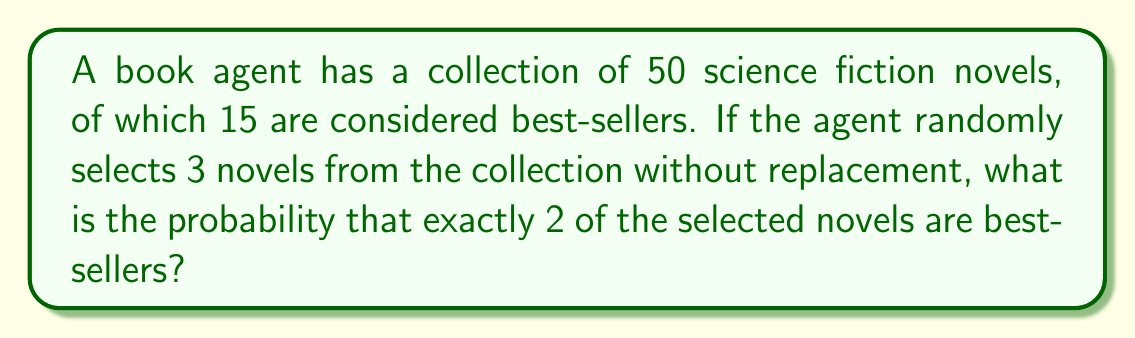Provide a solution to this math problem. To solve this problem, we'll use the hypergeometric distribution, which is appropriate for sampling without replacement from a finite population.

Let's define our parameters:
- N = 50 (total number of novels)
- K = 15 (number of best-sellers)
- n = 3 (number of novels selected)
- k = 2 (number of best-sellers we want in our selection)

The probability of selecting exactly 2 best-sellers out of 3 selections is given by:

$$P(X=2) = \frac{\binom{K}{k} \binom{N-K}{n-k}}{\binom{N}{n}}$$

Where $\binom{a}{b}$ represents the binomial coefficient "a choose b".

Step 1: Calculate $\binom{K}{k} = \binom{15}{2}$
$$\binom{15}{2} = \frac{15!}{2!(15-2)!} = \frac{15 \cdot 14}{2 \cdot 1} = 105$$

Step 2: Calculate $\binom{N-K}{n-k} = \binom{35}{1}$
$$\binom{35}{1} = \frac{35!}{1!(35-1)!} = 35$$

Step 3: Calculate $\binom{N}{n} = \binom{50}{3}$
$$\binom{50}{3} = \frac{50!}{3!(50-3)!} = \frac{50 \cdot 49 \cdot 48}{3 \cdot 2 \cdot 1} = 19,600$$

Step 4: Apply the formula
$$P(X=2) = \frac{105 \cdot 35}{19,600} = \frac{3,675}{19,600} = 0.1875$$

Therefore, the probability of selecting exactly 2 best-sellers when randomly choosing 3 novels from the collection is 0.1875 or 18.75%.
Answer: $\frac{3,675}{19,600}$ or $0.1875$ or $18.75\%$ 